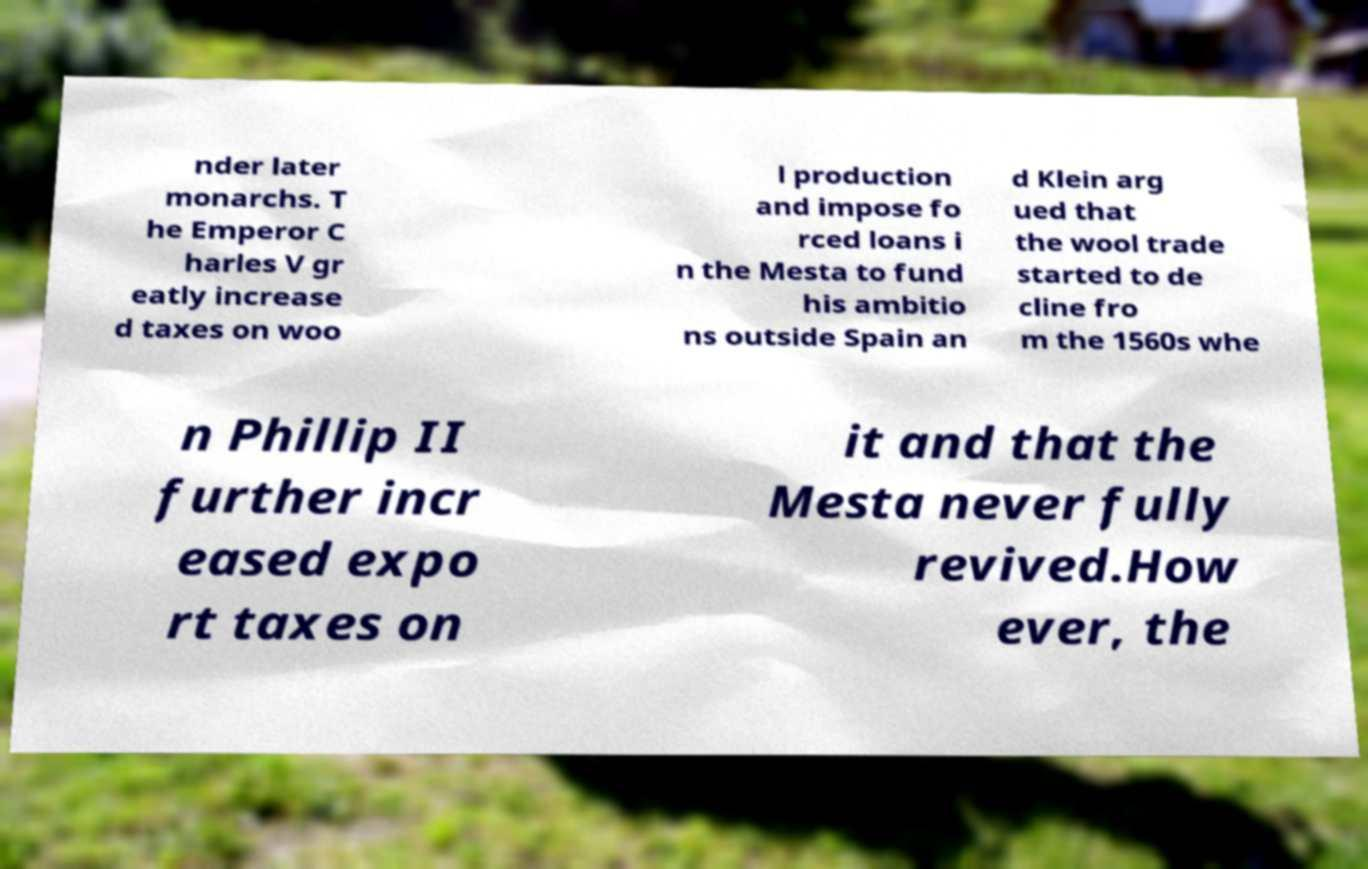What messages or text are displayed in this image? I need them in a readable, typed format. nder later monarchs. T he Emperor C harles V gr eatly increase d taxes on woo l production and impose fo rced loans i n the Mesta to fund his ambitio ns outside Spain an d Klein arg ued that the wool trade started to de cline fro m the 1560s whe n Phillip II further incr eased expo rt taxes on it and that the Mesta never fully revived.How ever, the 